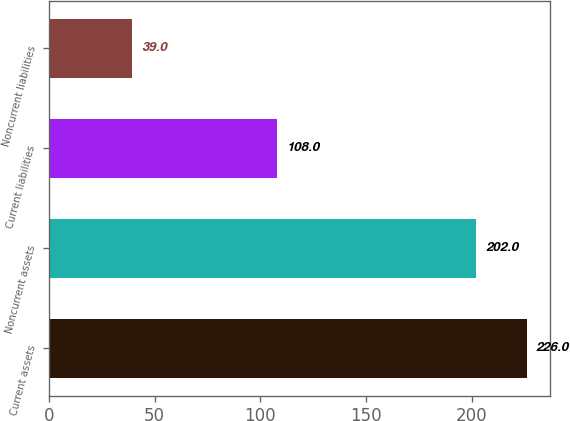Convert chart. <chart><loc_0><loc_0><loc_500><loc_500><bar_chart><fcel>Current assets<fcel>Noncurrent assets<fcel>Current liabilities<fcel>Noncurrent liabilities<nl><fcel>226<fcel>202<fcel>108<fcel>39<nl></chart> 